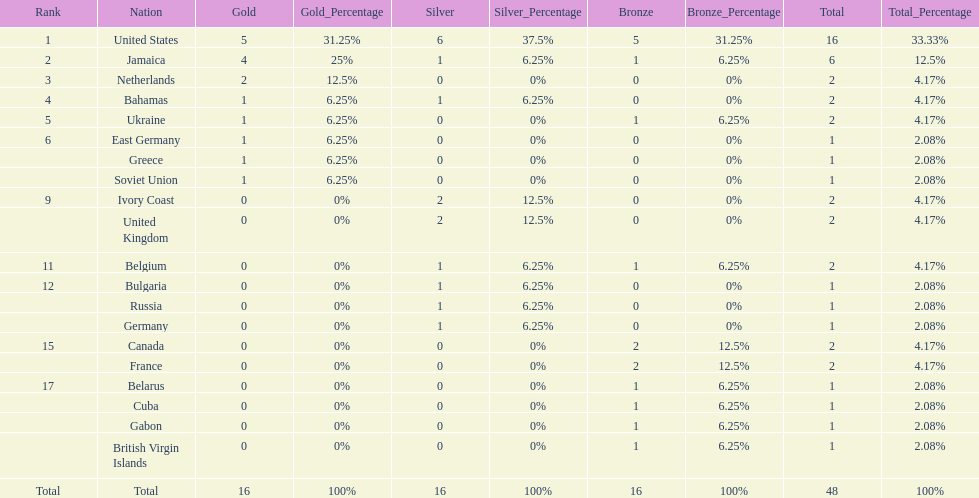What country won the most silver medals? United States. 